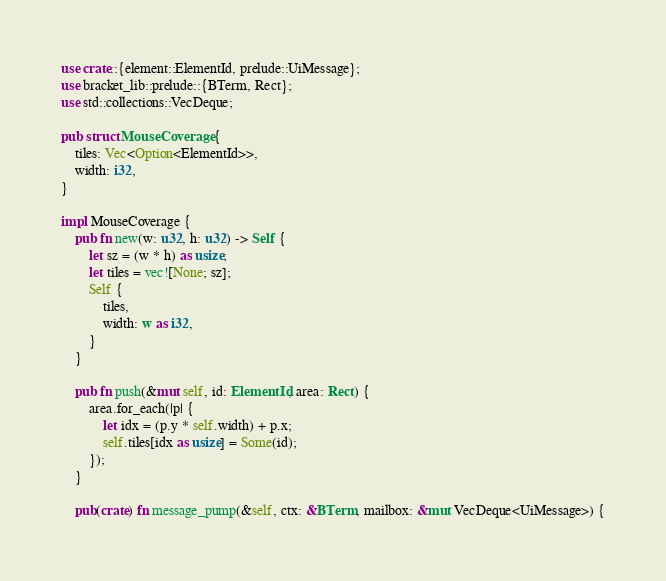<code> <loc_0><loc_0><loc_500><loc_500><_Rust_>use crate::{element::ElementId, prelude::UiMessage};
use bracket_lib::prelude::{BTerm, Rect};
use std::collections::VecDeque;

pub struct MouseCoverage {
    tiles: Vec<Option<ElementId>>,
    width: i32,
}

impl MouseCoverage {
    pub fn new(w: u32, h: u32) -> Self {
        let sz = (w * h) as usize;
        let tiles = vec![None; sz];
        Self {
            tiles,
            width: w as i32,
        }
    }

    pub fn push(&mut self, id: ElementId, area: Rect) {
        area.for_each(|p| {
            let idx = (p.y * self.width) + p.x;
            self.tiles[idx as usize] = Some(id);
        });
    }

    pub(crate) fn message_pump(&self, ctx: &BTerm, mailbox: &mut VecDeque<UiMessage>) {</code> 